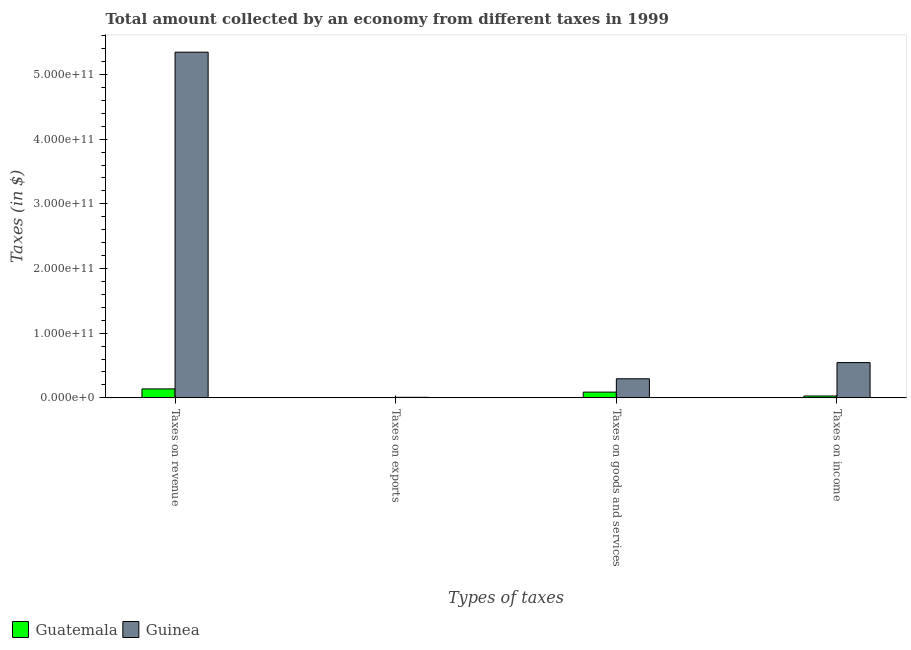How many different coloured bars are there?
Offer a terse response. 2. Are the number of bars per tick equal to the number of legend labels?
Your answer should be very brief. Yes. Are the number of bars on each tick of the X-axis equal?
Keep it short and to the point. Yes. How many bars are there on the 3rd tick from the left?
Offer a terse response. 2. What is the label of the 3rd group of bars from the left?
Provide a short and direct response. Taxes on goods and services. What is the amount collected as tax on goods in Guinea?
Provide a succinct answer. 2.95e+1. Across all countries, what is the maximum amount collected as tax on exports?
Your answer should be very brief. 8.80e+08. Across all countries, what is the minimum amount collected as tax on revenue?
Your answer should be compact. 1.39e+1. In which country was the amount collected as tax on exports maximum?
Provide a short and direct response. Guinea. In which country was the amount collected as tax on revenue minimum?
Your answer should be compact. Guatemala. What is the total amount collected as tax on goods in the graph?
Your answer should be very brief. 3.84e+1. What is the difference between the amount collected as tax on goods in Guinea and that in Guatemala?
Give a very brief answer. 2.06e+1. What is the difference between the amount collected as tax on exports in Guatemala and the amount collected as tax on income in Guinea?
Ensure brevity in your answer.  -5.46e+1. What is the average amount collected as tax on revenue per country?
Give a very brief answer. 2.74e+11. What is the difference between the amount collected as tax on income and amount collected as tax on revenue in Guatemala?
Give a very brief answer. -1.10e+1. What is the ratio of the amount collected as tax on goods in Guinea to that in Guatemala?
Your answer should be very brief. 3.32. What is the difference between the highest and the second highest amount collected as tax on exports?
Provide a succinct answer. 8.77e+08. What is the difference between the highest and the lowest amount collected as tax on exports?
Ensure brevity in your answer.  8.77e+08. Is the sum of the amount collected as tax on income in Guinea and Guatemala greater than the maximum amount collected as tax on goods across all countries?
Provide a succinct answer. Yes. Is it the case that in every country, the sum of the amount collected as tax on goods and amount collected as tax on exports is greater than the sum of amount collected as tax on revenue and amount collected as tax on income?
Offer a very short reply. No. What does the 2nd bar from the left in Taxes on revenue represents?
Keep it short and to the point. Guinea. What does the 1st bar from the right in Taxes on revenue represents?
Keep it short and to the point. Guinea. What is the difference between two consecutive major ticks on the Y-axis?
Offer a terse response. 1.00e+11. Where does the legend appear in the graph?
Provide a succinct answer. Bottom left. How many legend labels are there?
Your response must be concise. 2. How are the legend labels stacked?
Ensure brevity in your answer.  Horizontal. What is the title of the graph?
Your answer should be very brief. Total amount collected by an economy from different taxes in 1999. Does "Philippines" appear as one of the legend labels in the graph?
Your response must be concise. No. What is the label or title of the X-axis?
Provide a succinct answer. Types of taxes. What is the label or title of the Y-axis?
Offer a terse response. Taxes (in $). What is the Taxes (in $) of Guatemala in Taxes on revenue?
Your answer should be compact. 1.39e+1. What is the Taxes (in $) in Guinea in Taxes on revenue?
Offer a terse response. 5.34e+11. What is the Taxes (in $) of Guatemala in Taxes on exports?
Your response must be concise. 2.61e+06. What is the Taxes (in $) of Guinea in Taxes on exports?
Give a very brief answer. 8.80e+08. What is the Taxes (in $) in Guatemala in Taxes on goods and services?
Keep it short and to the point. 8.89e+09. What is the Taxes (in $) in Guinea in Taxes on goods and services?
Offer a terse response. 2.95e+1. What is the Taxes (in $) in Guatemala in Taxes on income?
Provide a succinct answer. 2.90e+09. What is the Taxes (in $) of Guinea in Taxes on income?
Offer a very short reply. 5.46e+1. Across all Types of taxes, what is the maximum Taxes (in $) of Guatemala?
Offer a very short reply. 1.39e+1. Across all Types of taxes, what is the maximum Taxes (in $) of Guinea?
Your answer should be compact. 5.34e+11. Across all Types of taxes, what is the minimum Taxes (in $) in Guatemala?
Provide a short and direct response. 2.61e+06. Across all Types of taxes, what is the minimum Taxes (in $) of Guinea?
Offer a terse response. 8.80e+08. What is the total Taxes (in $) in Guatemala in the graph?
Keep it short and to the point. 2.56e+1. What is the total Taxes (in $) in Guinea in the graph?
Offer a very short reply. 6.19e+11. What is the difference between the Taxes (in $) of Guatemala in Taxes on revenue and that in Taxes on exports?
Make the answer very short. 1.39e+1. What is the difference between the Taxes (in $) of Guinea in Taxes on revenue and that in Taxes on exports?
Offer a very short reply. 5.34e+11. What is the difference between the Taxes (in $) of Guatemala in Taxes on revenue and that in Taxes on goods and services?
Make the answer very short. 4.98e+09. What is the difference between the Taxes (in $) of Guinea in Taxes on revenue and that in Taxes on goods and services?
Ensure brevity in your answer.  5.05e+11. What is the difference between the Taxes (in $) of Guatemala in Taxes on revenue and that in Taxes on income?
Provide a short and direct response. 1.10e+1. What is the difference between the Taxes (in $) in Guinea in Taxes on revenue and that in Taxes on income?
Make the answer very short. 4.80e+11. What is the difference between the Taxes (in $) of Guatemala in Taxes on exports and that in Taxes on goods and services?
Offer a terse response. -8.88e+09. What is the difference between the Taxes (in $) of Guinea in Taxes on exports and that in Taxes on goods and services?
Make the answer very short. -2.86e+1. What is the difference between the Taxes (in $) in Guatemala in Taxes on exports and that in Taxes on income?
Provide a short and direct response. -2.89e+09. What is the difference between the Taxes (in $) of Guinea in Taxes on exports and that in Taxes on income?
Keep it short and to the point. -5.37e+1. What is the difference between the Taxes (in $) of Guatemala in Taxes on goods and services and that in Taxes on income?
Keep it short and to the point. 5.99e+09. What is the difference between the Taxes (in $) of Guinea in Taxes on goods and services and that in Taxes on income?
Provide a short and direct response. -2.50e+1. What is the difference between the Taxes (in $) of Guatemala in Taxes on revenue and the Taxes (in $) of Guinea in Taxes on exports?
Your answer should be very brief. 1.30e+1. What is the difference between the Taxes (in $) of Guatemala in Taxes on revenue and the Taxes (in $) of Guinea in Taxes on goods and services?
Provide a succinct answer. -1.57e+1. What is the difference between the Taxes (in $) of Guatemala in Taxes on revenue and the Taxes (in $) of Guinea in Taxes on income?
Keep it short and to the point. -4.07e+1. What is the difference between the Taxes (in $) in Guatemala in Taxes on exports and the Taxes (in $) in Guinea in Taxes on goods and services?
Your response must be concise. -2.95e+1. What is the difference between the Taxes (in $) in Guatemala in Taxes on exports and the Taxes (in $) in Guinea in Taxes on income?
Your response must be concise. -5.46e+1. What is the difference between the Taxes (in $) in Guatemala in Taxes on goods and services and the Taxes (in $) in Guinea in Taxes on income?
Give a very brief answer. -4.57e+1. What is the average Taxes (in $) of Guatemala per Types of taxes?
Keep it short and to the point. 6.41e+09. What is the average Taxes (in $) of Guinea per Types of taxes?
Offer a terse response. 1.55e+11. What is the difference between the Taxes (in $) of Guatemala and Taxes (in $) of Guinea in Taxes on revenue?
Your response must be concise. -5.21e+11. What is the difference between the Taxes (in $) in Guatemala and Taxes (in $) in Guinea in Taxes on exports?
Provide a short and direct response. -8.77e+08. What is the difference between the Taxes (in $) of Guatemala and Taxes (in $) of Guinea in Taxes on goods and services?
Your answer should be very brief. -2.06e+1. What is the difference between the Taxes (in $) of Guatemala and Taxes (in $) of Guinea in Taxes on income?
Your answer should be compact. -5.17e+1. What is the ratio of the Taxes (in $) of Guatemala in Taxes on revenue to that in Taxes on exports?
Ensure brevity in your answer.  5311.52. What is the ratio of the Taxes (in $) in Guinea in Taxes on revenue to that in Taxes on exports?
Your answer should be compact. 607.33. What is the ratio of the Taxes (in $) of Guatemala in Taxes on revenue to that in Taxes on goods and services?
Make the answer very short. 1.56. What is the ratio of the Taxes (in $) of Guinea in Taxes on revenue to that in Taxes on goods and services?
Make the answer very short. 18.1. What is the ratio of the Taxes (in $) of Guatemala in Taxes on revenue to that in Taxes on income?
Offer a terse response. 4.79. What is the ratio of the Taxes (in $) in Guinea in Taxes on revenue to that in Taxes on income?
Give a very brief answer. 9.8. What is the ratio of the Taxes (in $) of Guatemala in Taxes on exports to that in Taxes on goods and services?
Offer a terse response. 0. What is the ratio of the Taxes (in $) of Guinea in Taxes on exports to that in Taxes on goods and services?
Your answer should be compact. 0.03. What is the ratio of the Taxes (in $) in Guatemala in Taxes on exports to that in Taxes on income?
Your answer should be very brief. 0. What is the ratio of the Taxes (in $) in Guinea in Taxes on exports to that in Taxes on income?
Your response must be concise. 0.02. What is the ratio of the Taxes (in $) in Guatemala in Taxes on goods and services to that in Taxes on income?
Keep it short and to the point. 3.07. What is the ratio of the Taxes (in $) of Guinea in Taxes on goods and services to that in Taxes on income?
Provide a short and direct response. 0.54. What is the difference between the highest and the second highest Taxes (in $) in Guatemala?
Your answer should be compact. 4.98e+09. What is the difference between the highest and the second highest Taxes (in $) of Guinea?
Your answer should be very brief. 4.80e+11. What is the difference between the highest and the lowest Taxes (in $) of Guatemala?
Provide a short and direct response. 1.39e+1. What is the difference between the highest and the lowest Taxes (in $) in Guinea?
Make the answer very short. 5.34e+11. 